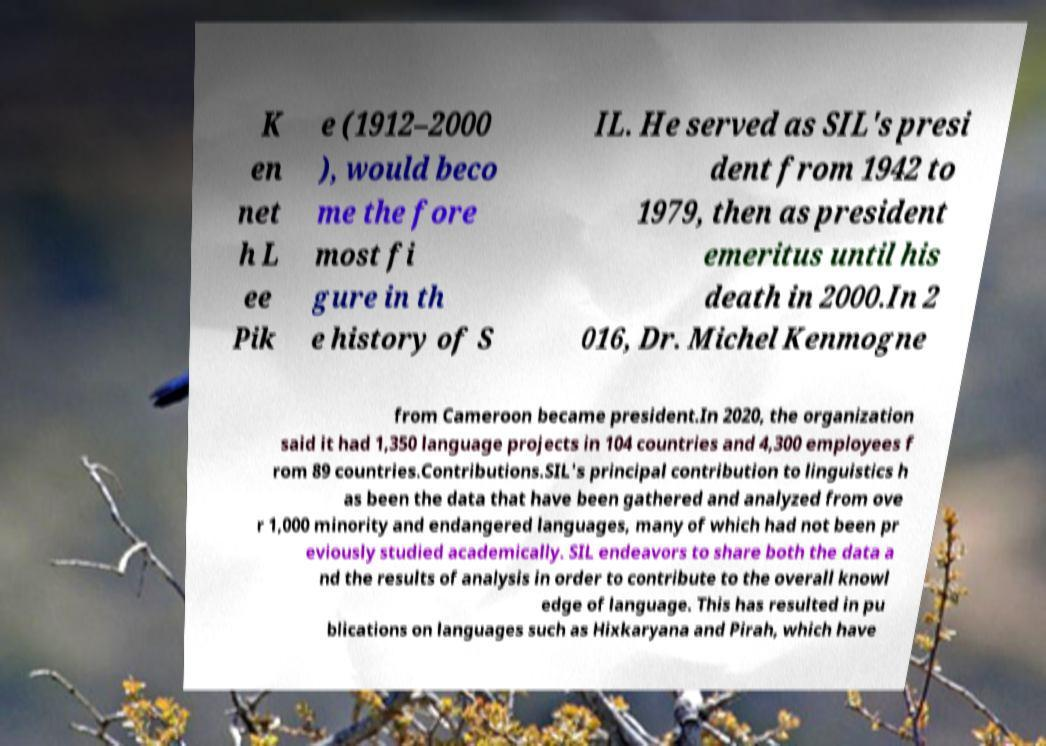Please read and relay the text visible in this image. What does it say? K en net h L ee Pik e (1912–2000 ), would beco me the fore most fi gure in th e history of S IL. He served as SIL's presi dent from 1942 to 1979, then as president emeritus until his death in 2000.In 2 016, Dr. Michel Kenmogne from Cameroon became president.In 2020, the organization said it had 1,350 language projects in 104 countries and 4,300 employees f rom 89 countries.Contributions.SIL's principal contribution to linguistics h as been the data that have been gathered and analyzed from ove r 1,000 minority and endangered languages, many of which had not been pr eviously studied academically. SIL endeavors to share both the data a nd the results of analysis in order to contribute to the overall knowl edge of language. This has resulted in pu blications on languages such as Hixkaryana and Pirah, which have 